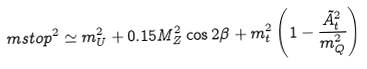Convert formula to latex. <formula><loc_0><loc_0><loc_500><loc_500>\ m s t o p ^ { 2 } \simeq m _ { U } ^ { 2 } + 0 . 1 5 M _ { Z } ^ { 2 } \cos 2 \beta + m _ { t } ^ { 2 } \left ( 1 - \frac { \tilde { A } _ { t } ^ { 2 } } { m _ { Q } ^ { 2 } } \right )</formula> 